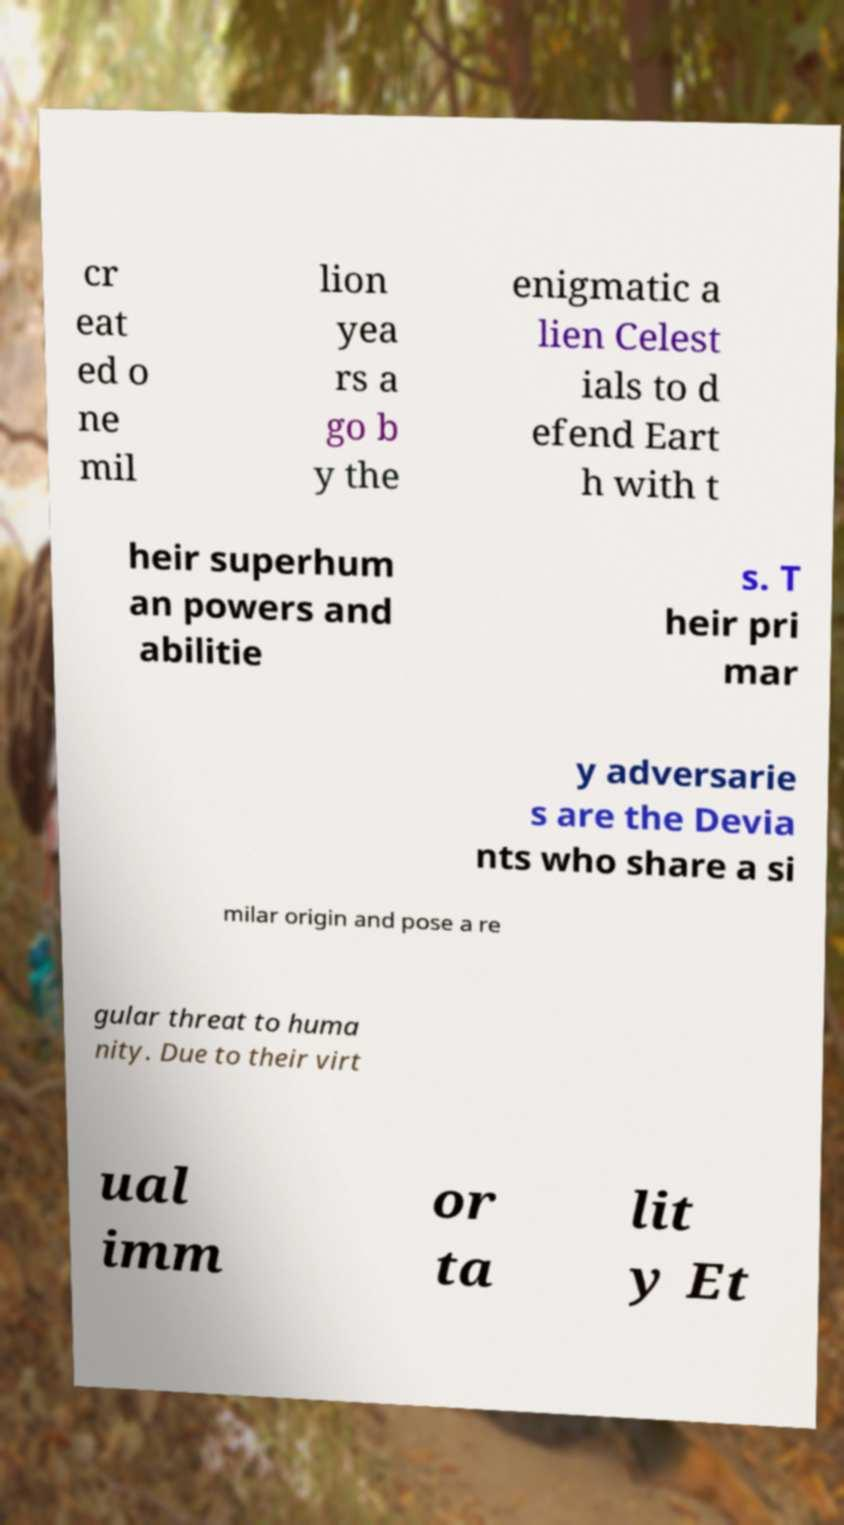There's text embedded in this image that I need extracted. Can you transcribe it verbatim? cr eat ed o ne mil lion yea rs a go b y the enigmatic a lien Celest ials to d efend Eart h with t heir superhum an powers and abilitie s. T heir pri mar y adversarie s are the Devia nts who share a si milar origin and pose a re gular threat to huma nity. Due to their virt ual imm or ta lit y Et 